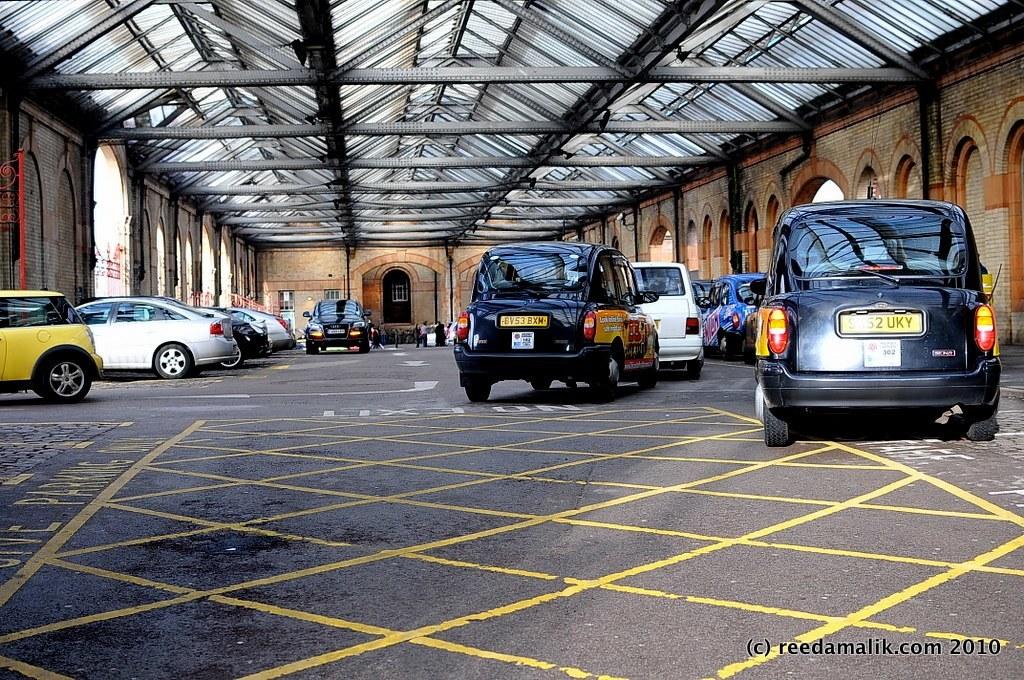What is the date in the bottom corner of this photo?
Your answer should be compact. 2010. What is the plate number on the right car?
Offer a very short reply. Unanswerable. 